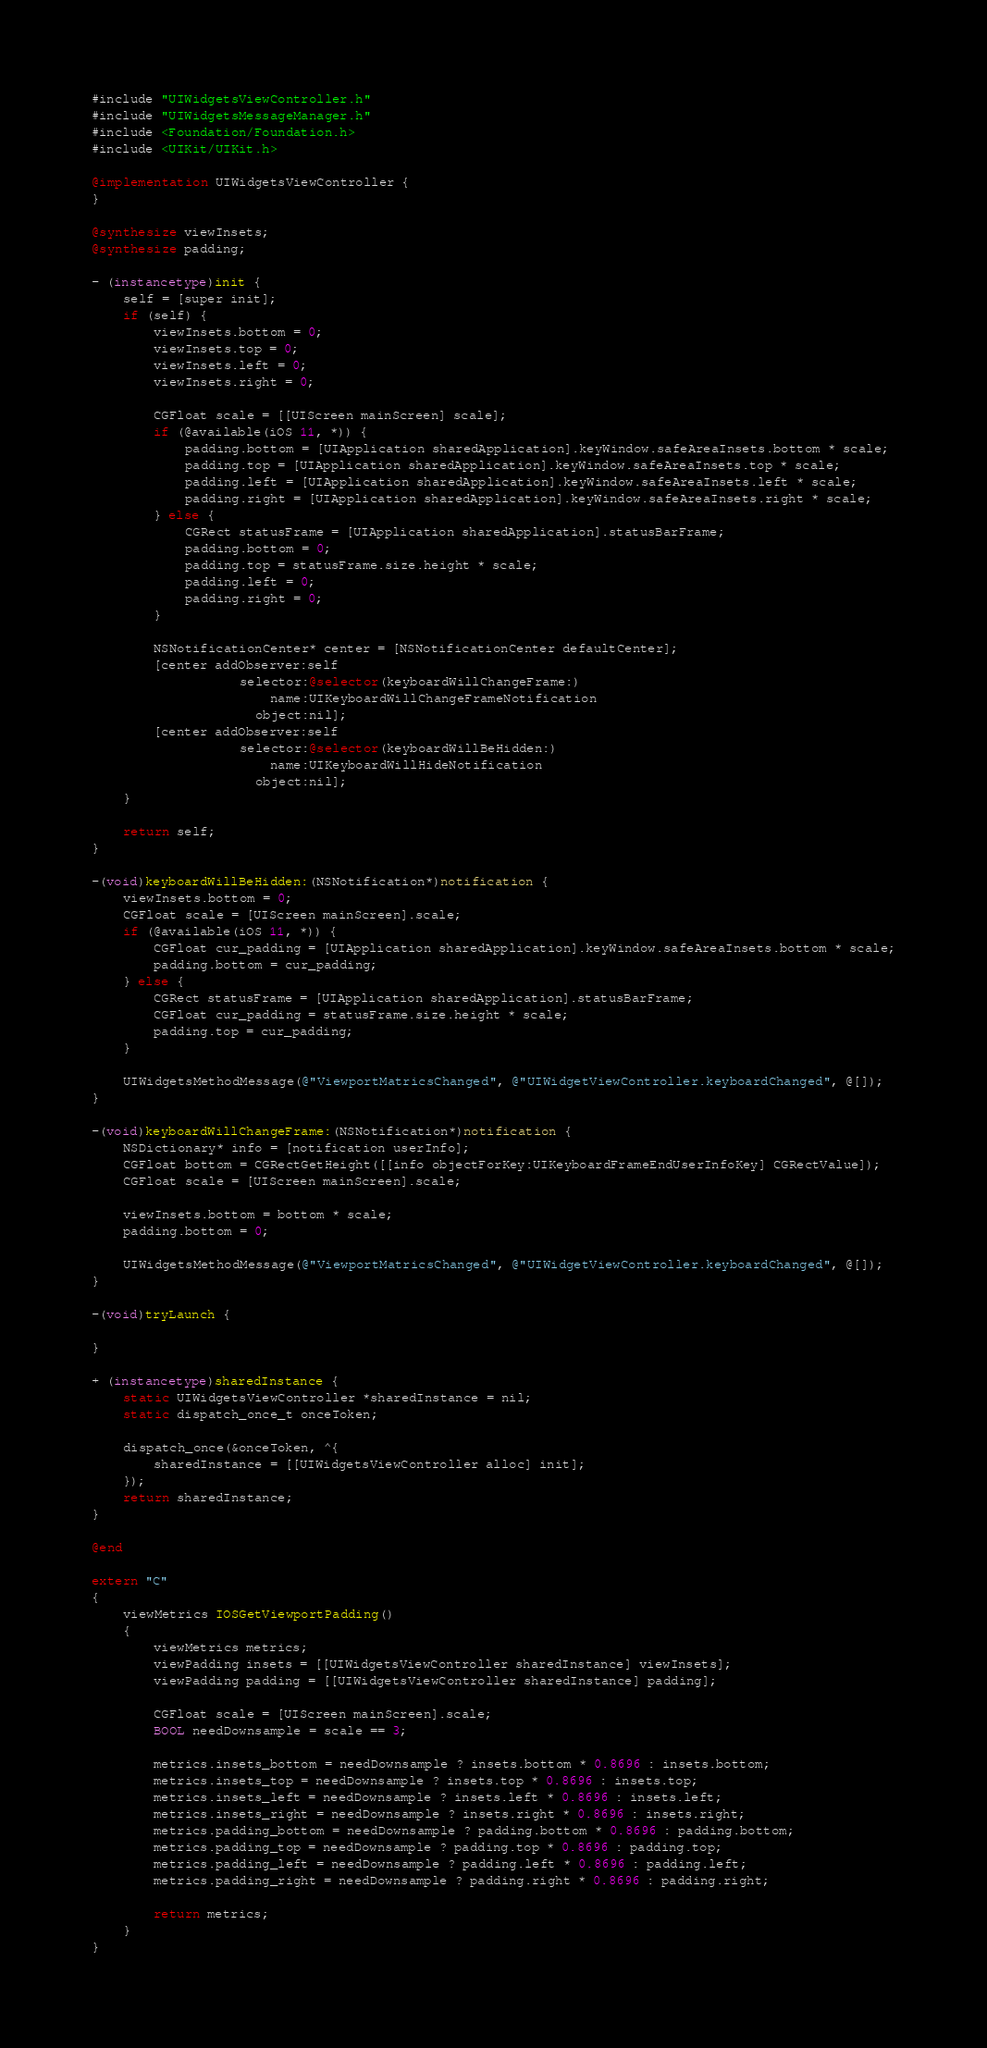Convert code to text. <code><loc_0><loc_0><loc_500><loc_500><_ObjectiveC_>#include "UIWidgetsViewController.h"
#include "UIWidgetsMessageManager.h"
#include <Foundation/Foundation.h>
#include <UIKit/UIKit.h>

@implementation UIWidgetsViewController {
}

@synthesize viewInsets;
@synthesize padding;

- (instancetype)init {
    self = [super init];
    if (self) {
        viewInsets.bottom = 0;
        viewInsets.top = 0;
        viewInsets.left = 0;
        viewInsets.right = 0;

        CGFloat scale = [[UIScreen mainScreen] scale];
        if (@available(iOS 11, *)) {
            padding.bottom = [UIApplication sharedApplication].keyWindow.safeAreaInsets.bottom * scale;
            padding.top = [UIApplication sharedApplication].keyWindow.safeAreaInsets.top * scale;
            padding.left = [UIApplication sharedApplication].keyWindow.safeAreaInsets.left * scale;
            padding.right = [UIApplication sharedApplication].keyWindow.safeAreaInsets.right * scale;
        } else {
            CGRect statusFrame = [UIApplication sharedApplication].statusBarFrame;
            padding.bottom = 0;
            padding.top = statusFrame.size.height * scale;
            padding.left = 0;
            padding.right = 0;
        }

        NSNotificationCenter* center = [NSNotificationCenter defaultCenter];
        [center addObserver:self
                   selector:@selector(keyboardWillChangeFrame:)
                       name:UIKeyboardWillChangeFrameNotification
                     object:nil];
        [center addObserver:self
                   selector:@selector(keyboardWillBeHidden:)
                       name:UIKeyboardWillHideNotification
                     object:nil];
    }

    return self;
}

-(void)keyboardWillBeHidden:(NSNotification*)notification {
    viewInsets.bottom = 0;
    CGFloat scale = [UIScreen mainScreen].scale;
    if (@available(iOS 11, *)) {
        CGFloat cur_padding = [UIApplication sharedApplication].keyWindow.safeAreaInsets.bottom * scale;
        padding.bottom = cur_padding;
    } else {
        CGRect statusFrame = [UIApplication sharedApplication].statusBarFrame;
        CGFloat cur_padding = statusFrame.size.height * scale;
        padding.top = cur_padding;
    }

    UIWidgetsMethodMessage(@"ViewportMatricsChanged", @"UIWidgetViewController.keyboardChanged", @[]);
}

-(void)keyboardWillChangeFrame:(NSNotification*)notification {
    NSDictionary* info = [notification userInfo];
    CGFloat bottom = CGRectGetHeight([[info objectForKey:UIKeyboardFrameEndUserInfoKey] CGRectValue]);
    CGFloat scale = [UIScreen mainScreen].scale;

    viewInsets.bottom = bottom * scale;
    padding.bottom = 0;

    UIWidgetsMethodMessage(@"ViewportMatricsChanged", @"UIWidgetViewController.keyboardChanged", @[]);
}

-(void)tryLaunch {

}

+ (instancetype)sharedInstance {
    static UIWidgetsViewController *sharedInstance = nil;
    static dispatch_once_t onceToken;

    dispatch_once(&onceToken, ^{
        sharedInstance = [[UIWidgetsViewController alloc] init];
    });
    return sharedInstance;
}

@end

extern "C"
{
    viewMetrics IOSGetViewportPadding()
    {
        viewMetrics metrics;
        viewPadding insets = [[UIWidgetsViewController sharedInstance] viewInsets];
        viewPadding padding = [[UIWidgetsViewController sharedInstance] padding];

        CGFloat scale = [UIScreen mainScreen].scale;
        BOOL needDownsample = scale == 3;

        metrics.insets_bottom = needDownsample ? insets.bottom * 0.8696 : insets.bottom;
        metrics.insets_top = needDownsample ? insets.top * 0.8696 : insets.top;
        metrics.insets_left = needDownsample ? insets.left * 0.8696 : insets.left;
        metrics.insets_right = needDownsample ? insets.right * 0.8696 : insets.right;
        metrics.padding_bottom = needDownsample ? padding.bottom * 0.8696 : padding.bottom;
        metrics.padding_top = needDownsample ? padding.top * 0.8696 : padding.top;
        metrics.padding_left = needDownsample ? padding.left * 0.8696 : padding.left;
        metrics.padding_right = needDownsample ? padding.right * 0.8696 : padding.right;

        return metrics;
    }
}
</code> 